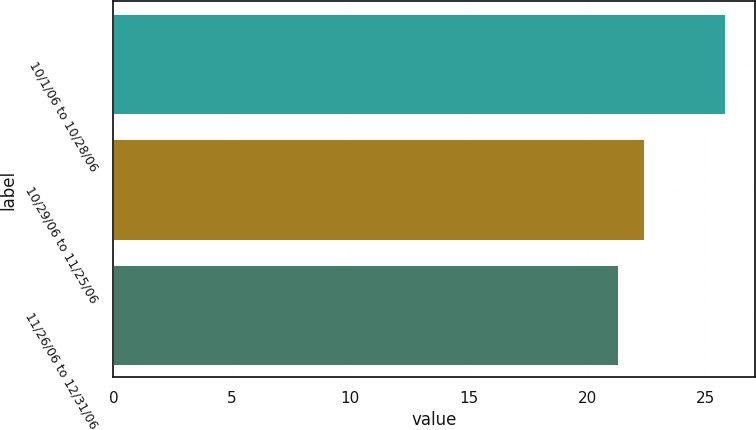Convert chart to OTSL. <chart><loc_0><loc_0><loc_500><loc_500><bar_chart><fcel>10/1/06 to 10/28/06<fcel>10/29/06 to 11/25/06<fcel>11/26/06 to 12/31/06<nl><fcel>25.82<fcel>22.39<fcel>21.29<nl></chart> 